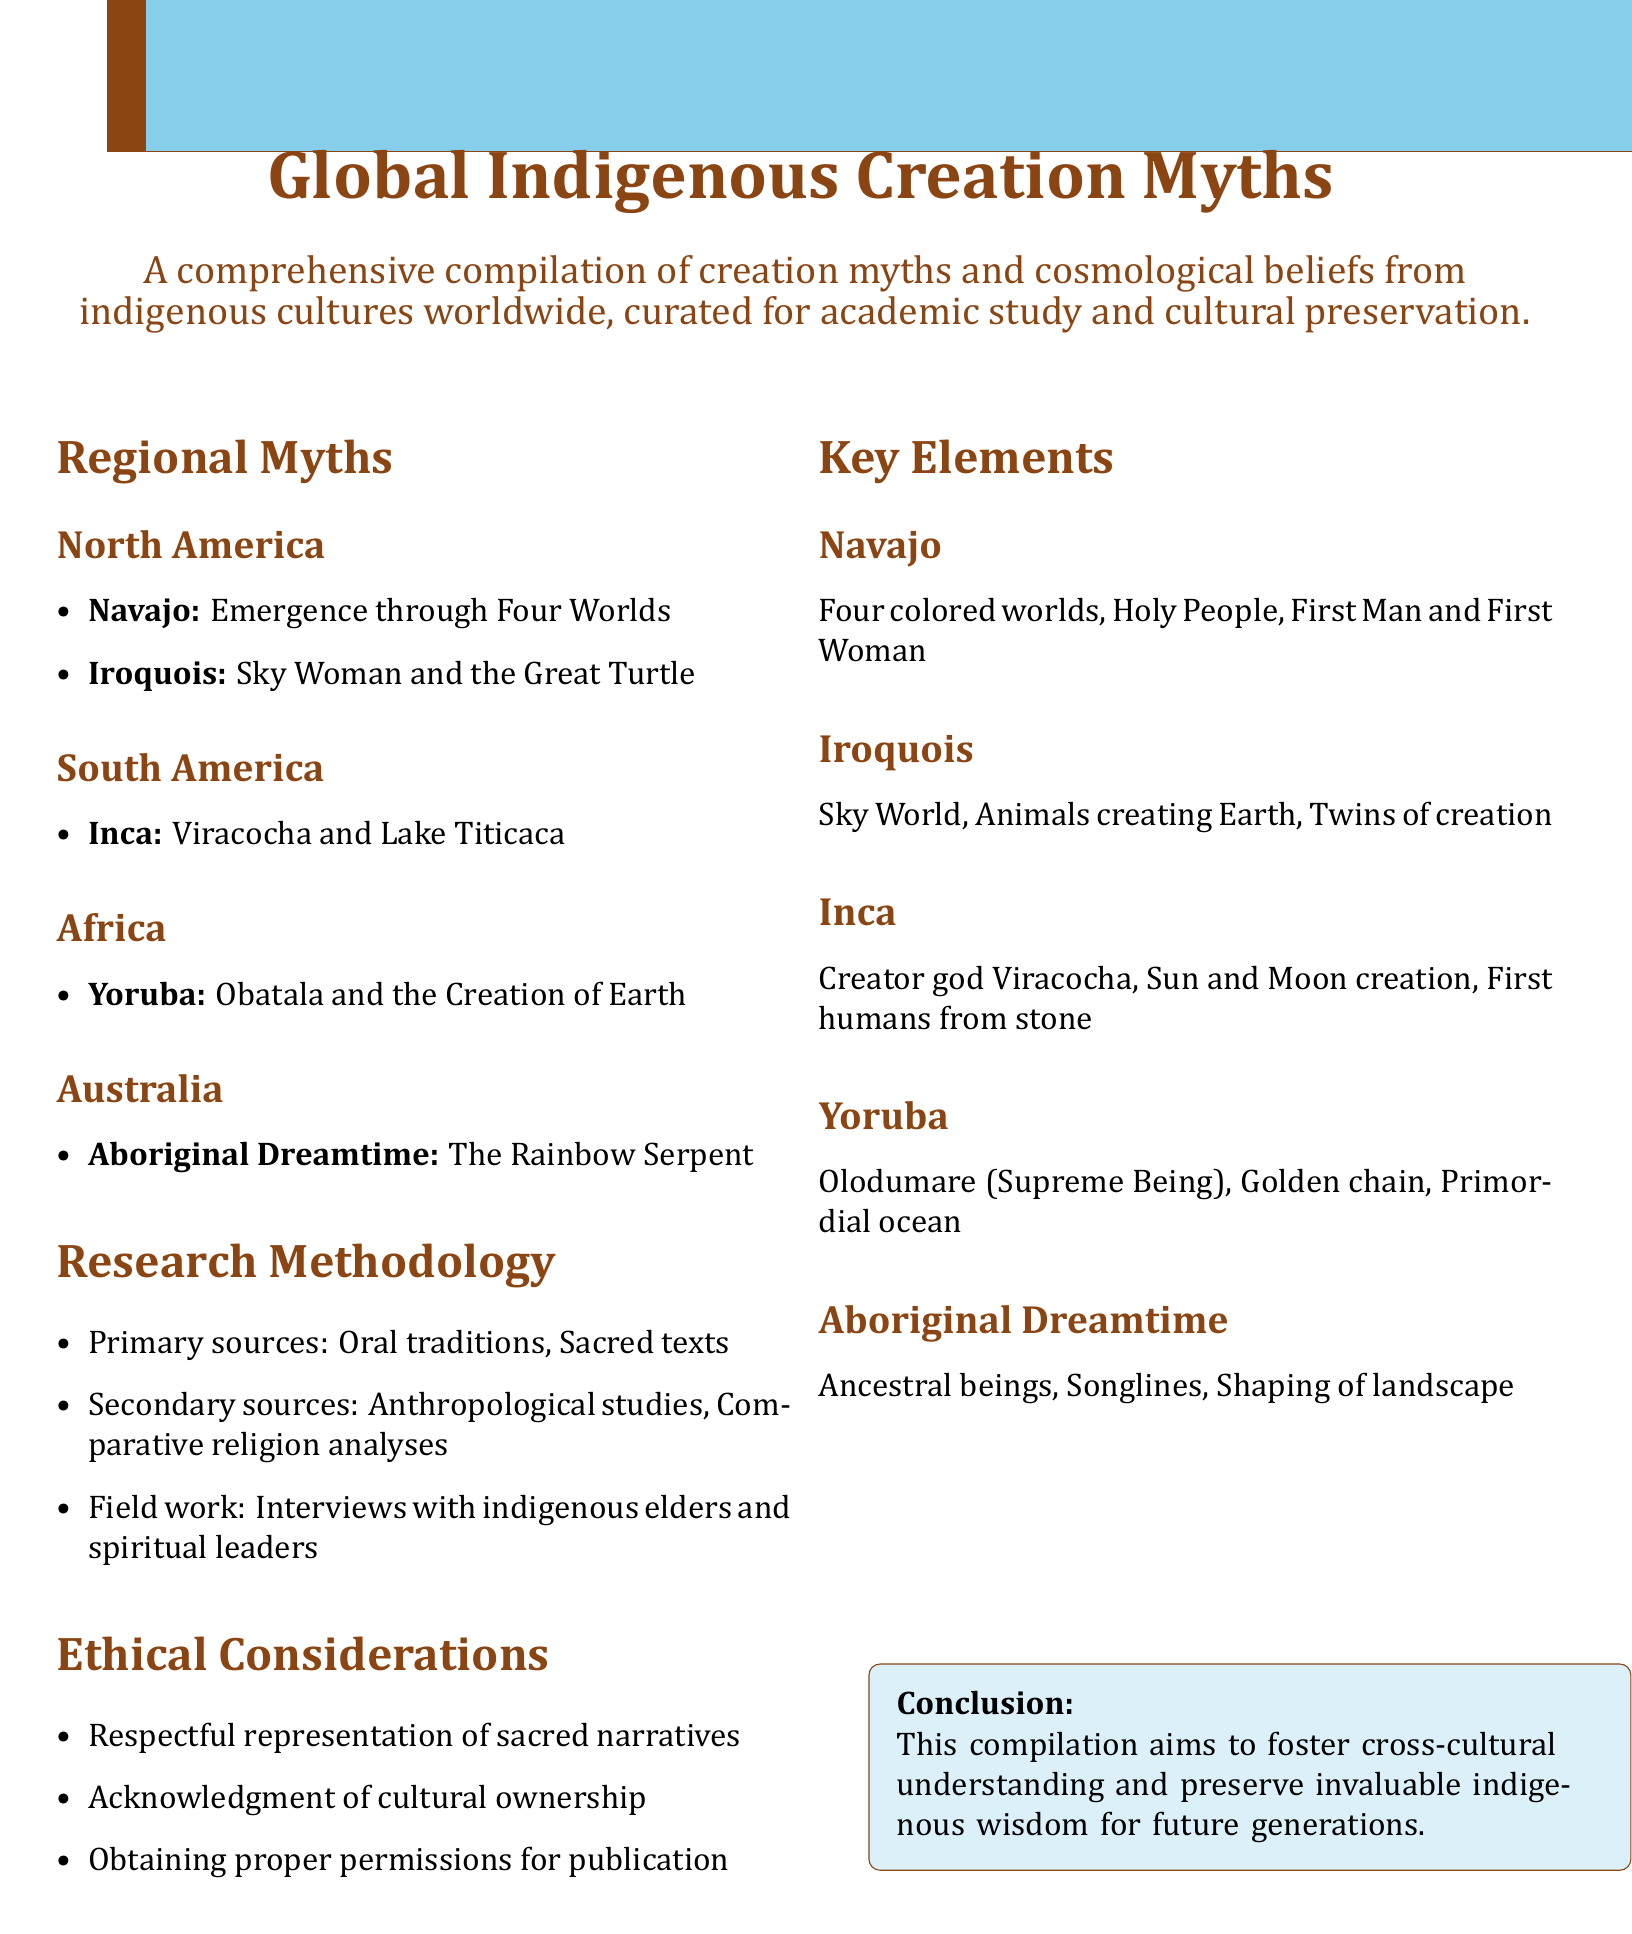what is the title of the document? The title is prominently displayed in a large font at the beginning of the document.
Answer: Global Indigenous Creation Myths how many regions are covered in the myths? The document lists the regions in the Regional Myths section, clearly identifying each separate area.
Answer: Five what is the Inca creator god? The Inca's creation myth specifies the name of the creator deity, which is highlighted in the text.
Answer: Viracocha which animal is associated with Iroquois creation? The document includes specific creatures involved in the Iroquois creation myth, identified in the item list.
Answer: Turtle what methodology involves field work? The Research Methodology section outlines methods including interviews, indicating a form of comprehensive study.
Answer: Field work what is the main ethical consideration mentioned? The document highlights important principles to uphold when representing indigenous narratives.
Answer: Respectful representation of sacred narratives which Australian myth is mentioned? The document lists a specific myth under the Australia section, denoting its cultural significance.
Answer: Aboriginal Dreamtime what element is common in all myths listed in the Key Elements? The Key Elements section summarizes significant components that are often present in creation stories across cultures.
Answer: Creation 